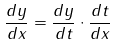<formula> <loc_0><loc_0><loc_500><loc_500>\frac { d y } { d x } = \frac { d y } { d t } \cdot \frac { d t } { d x }</formula> 